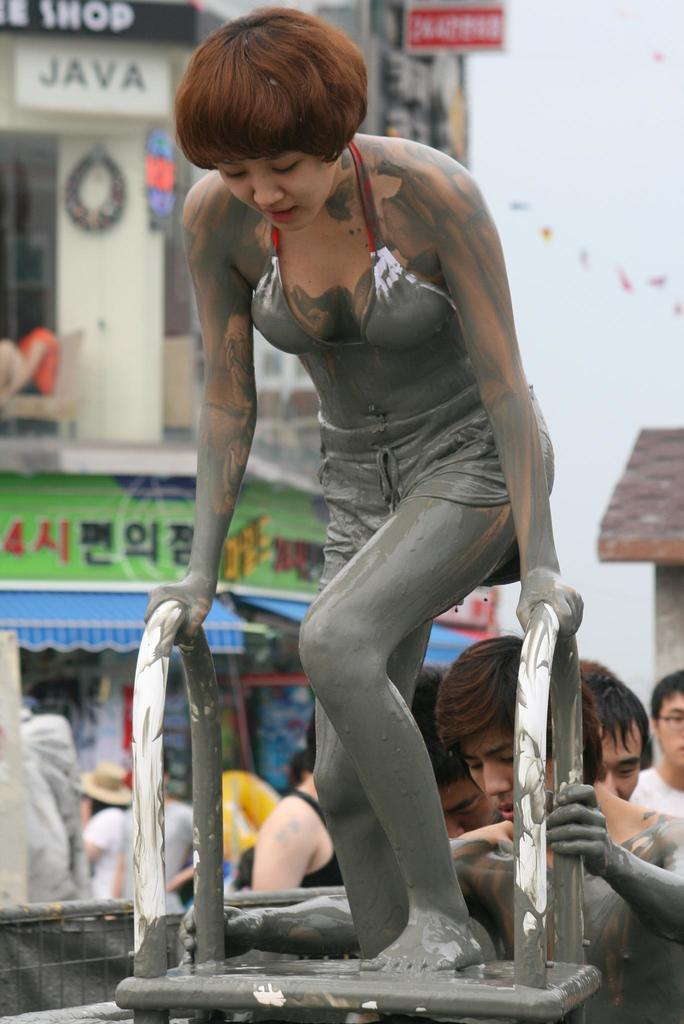What is the lady in the image doing? The lady is standing on a stand in the image. What can be seen in the background of the image? There are people and a building in the background of the image. What type of oatmeal is being served at the event in the image? There is no mention of oatmeal or any event in the image; it simply shows a lady standing on a stand with people and a building in the background. 